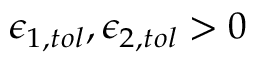Convert formula to latex. <formula><loc_0><loc_0><loc_500><loc_500>\epsilon _ { 1 , t o l } , \epsilon _ { 2 , t o l } > 0</formula> 